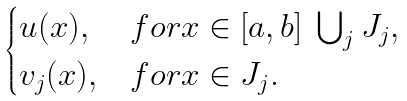Convert formula to latex. <formula><loc_0><loc_0><loc_500><loc_500>\begin{cases} u ( x ) , & f o r x \in [ a , b ] \ \bigcup _ { j } J _ { j } , \\ v _ { j } ( x ) , & f o r x \in J _ { j } . \end{cases}</formula> 